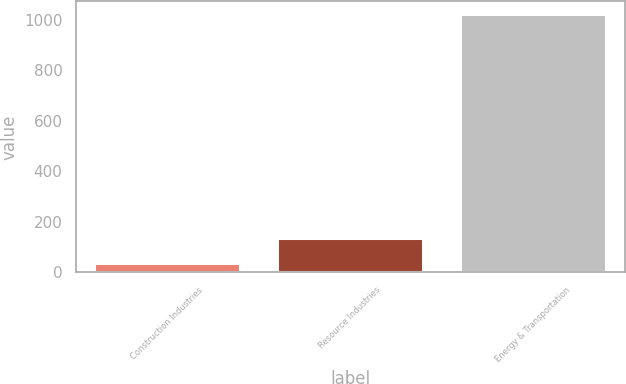<chart> <loc_0><loc_0><loc_500><loc_500><bar_chart><fcel>Construction Industries<fcel>Resource Industries<fcel>Energy & Transportation<nl><fcel>39<fcel>137.3<fcel>1022<nl></chart> 